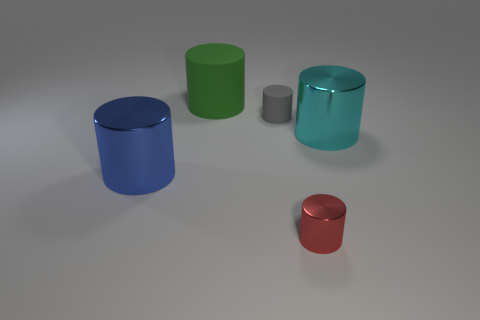What material is the cylinder that is on the right side of the tiny gray thing and behind the small red metallic object?
Provide a succinct answer. Metal. Is there a metal thing of the same size as the gray cylinder?
Offer a very short reply. Yes. What number of gray cylinders are there?
Provide a succinct answer. 1. How many cylinders are left of the gray matte cylinder?
Ensure brevity in your answer.  2. Do the big cyan object and the big green cylinder have the same material?
Provide a short and direct response. No. What number of big cylinders are both behind the blue metal cylinder and on the left side of the tiny red object?
Your response must be concise. 1. How many cyan things are either large metal cylinders or big objects?
Offer a terse response. 1. What size is the cyan metallic thing?
Your answer should be very brief. Large. What number of matte things are either big green cylinders or red spheres?
Give a very brief answer. 1. Is the number of metal cylinders less than the number of large blue cylinders?
Keep it short and to the point. No. 